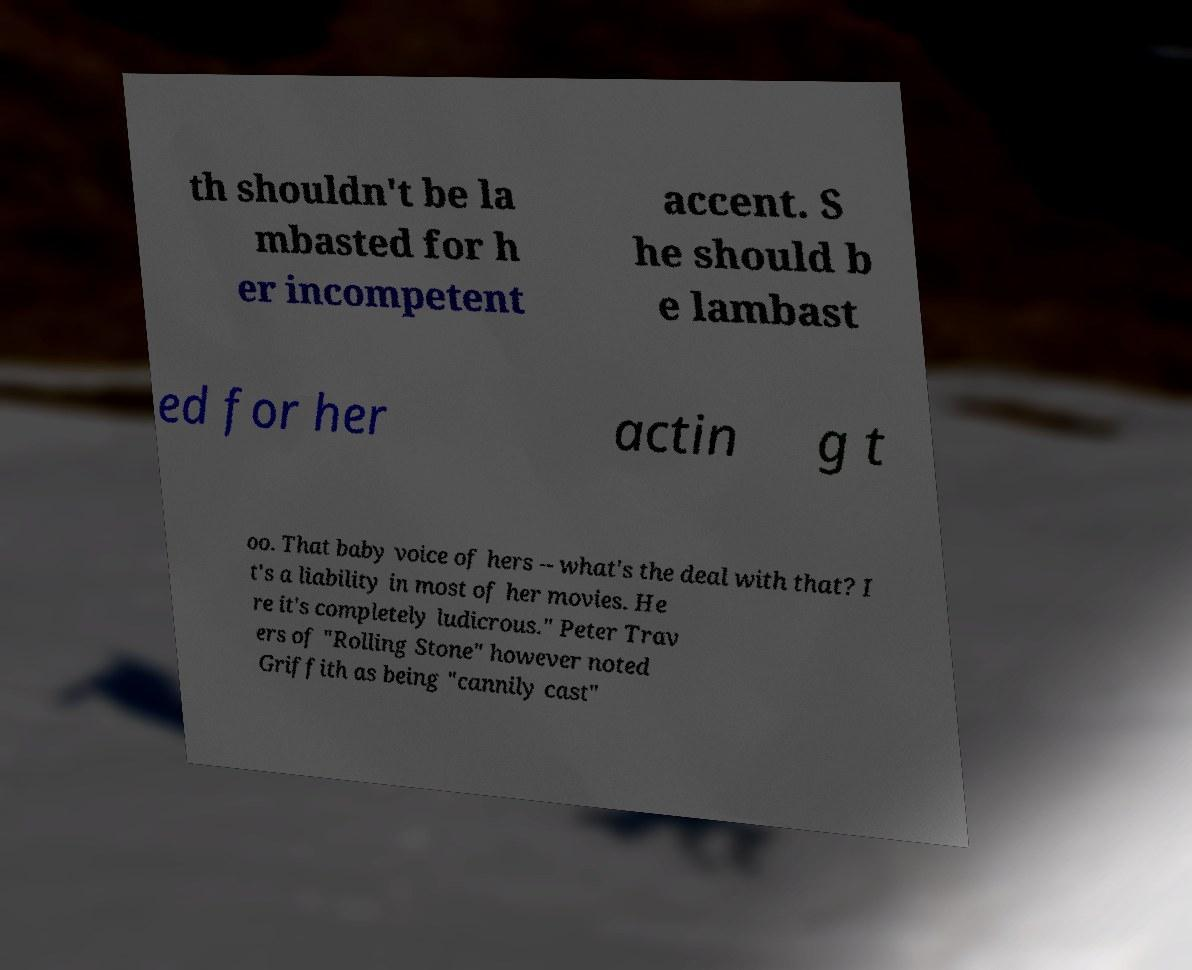Could you assist in decoding the text presented in this image and type it out clearly? th shouldn't be la mbasted for h er incompetent accent. S he should b e lambast ed for her actin g t oo. That baby voice of hers -- what's the deal with that? I t's a liability in most of her movies. He re it's completely ludicrous." Peter Trav ers of "Rolling Stone" however noted Griffith as being "cannily cast" 